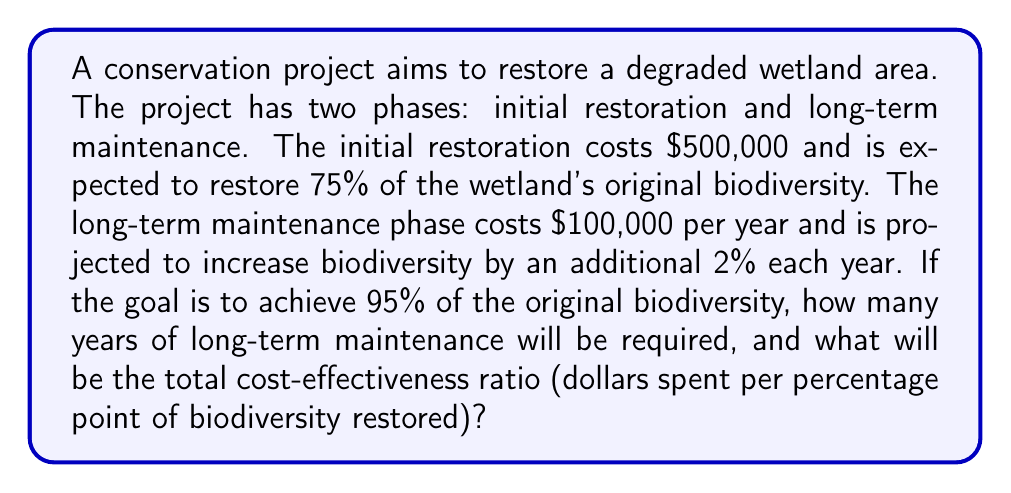What is the answer to this math problem? Let's approach this problem step-by-step:

1. Calculate the biodiversity restoration after the initial phase:
   Initial biodiversity restored = 75%

2. Calculate the remaining biodiversity to be restored:
   Remaining biodiversity = Target biodiversity - Initial biodiversity
   $$ 95\% - 75\% = 20\% $$

3. Calculate the number of years required for long-term maintenance:
   Years = Remaining biodiversity ÷ Annual biodiversity increase
   $$ \text{Years} = \frac{20\%}{2\% \text{ per year}} = 10 \text{ years} $$

4. Calculate the total cost:
   Initial restoration cost = $500,000
   Long-term maintenance cost = $100,000 × 10 years = $1,000,000
   Total cost = $500,000 + $1,000,000 = $1,500,000

5. Calculate the total biodiversity restored:
   $$ 75\% + (2\% \times 10 \text{ years}) = 95\% $$

6. Calculate the cost-effectiveness ratio:
   Cost-effectiveness ratio = Total cost ÷ Total biodiversity restored
   $$ \text{Cost-effectiveness ratio} = \frac{\$1,500,000}{95} = \$15,789.47 \text{ per percentage point} $$
Answer: 10 years of long-term maintenance will be required, and the total cost-effectiveness ratio will be $15,789.47 per percentage point of biodiversity restored. 